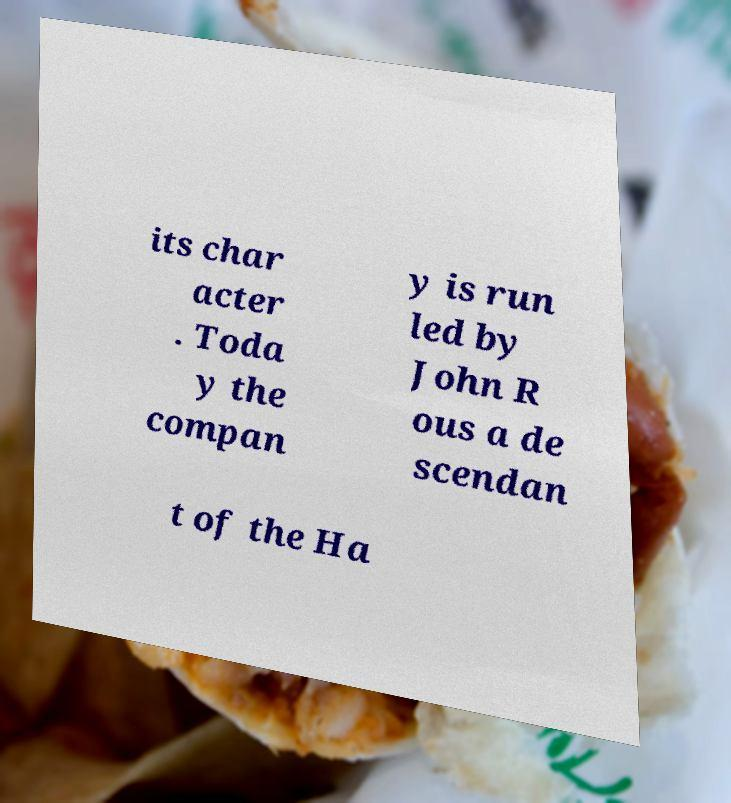Could you extract and type out the text from this image? its char acter . Toda y the compan y is run led by John R ous a de scendan t of the Ha 